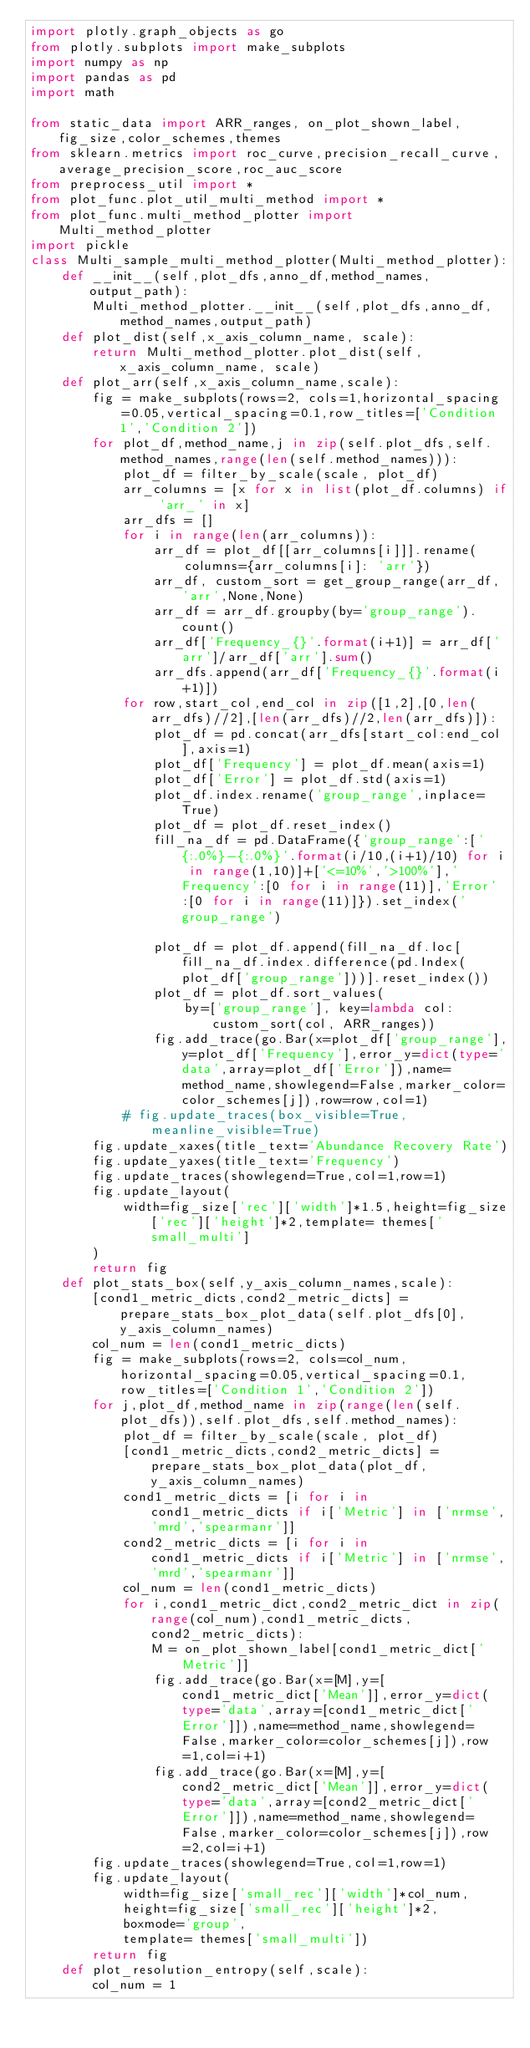<code> <loc_0><loc_0><loc_500><loc_500><_Python_>import plotly.graph_objects as go
from plotly.subplots import make_subplots
import numpy as np
import pandas as pd
import math

from static_data import ARR_ranges, on_plot_shown_label,fig_size,color_schemes,themes
from sklearn.metrics import roc_curve,precision_recall_curve,average_precision_score,roc_auc_score
from preprocess_util import *
from plot_func.plot_util_multi_method import *
from plot_func.multi_method_plotter import Multi_method_plotter
import pickle
class Multi_sample_multi_method_plotter(Multi_method_plotter):
    def __init__(self,plot_dfs,anno_df,method_names,output_path):
        Multi_method_plotter.__init__(self,plot_dfs,anno_df,method_names,output_path)
    def plot_dist(self,x_axis_column_name, scale):
        return Multi_method_plotter.plot_dist(self,x_axis_column_name, scale)
    def plot_arr(self,x_axis_column_name,scale):
        fig = make_subplots(rows=2, cols=1,horizontal_spacing=0.05,vertical_spacing=0.1,row_titles=['Condition 1','Condition 2'])
        for plot_df,method_name,j in zip(self.plot_dfs,self.method_names,range(len(self.method_names))):
            plot_df = filter_by_scale(scale, plot_df)
            arr_columns = [x for x in list(plot_df.columns) if 'arr_' in x]
            arr_dfs = []
            for i in range(len(arr_columns)):
                arr_df = plot_df[[arr_columns[i]]].rename(
                    columns={arr_columns[i]: 'arr'})
                arr_df, custom_sort = get_group_range(arr_df, 'arr',None,None)
                arr_df = arr_df.groupby(by='group_range').count()
                arr_df['Frequency_{}'.format(i+1)] = arr_df['arr']/arr_df['arr'].sum()
                arr_dfs.append(arr_df['Frequency_{}'.format(i+1)])
            for row,start_col,end_col in zip([1,2],[0,len(arr_dfs)//2],[len(arr_dfs)//2,len(arr_dfs)]):
                plot_df = pd.concat(arr_dfs[start_col:end_col],axis=1)
                plot_df['Frequency'] = plot_df.mean(axis=1)
                plot_df['Error'] = plot_df.std(axis=1)
                plot_df.index.rename('group_range',inplace=True)
                plot_df = plot_df.reset_index()
                fill_na_df = pd.DataFrame({'group_range':['{:.0%}-{:.0%}'.format(i/10,(i+1)/10) for i in range(1,10)]+['<=10%','>100%'],'Frequency':[0 for i in range(11)],'Error':[0 for i in range(11)]}).set_index('group_range')
                
                plot_df = plot_df.append(fill_na_df.loc[fill_na_df.index.difference(pd.Index(plot_df['group_range']))].reset_index())
                plot_df = plot_df.sort_values(
                    by=['group_range'], key=lambda col: custom_sort(col, ARR_ranges))
                fig.add_trace(go.Bar(x=plot_df['group_range'],y=plot_df['Frequency'],error_y=dict(type='data',array=plot_df['Error']),name=method_name,showlegend=False,marker_color=color_schemes[j]),row=row,col=1)
            # fig.update_traces(box_visible=True, meanline_visible=True)
        fig.update_xaxes(title_text='Abundance Recovery Rate')
        fig.update_yaxes(title_text='Frequency')
        fig.update_traces(showlegend=True,col=1,row=1)
        fig.update_layout(
            width=fig_size['rec']['width']*1.5,height=fig_size['rec']['height']*2,template= themes['small_multi']
        )
        return fig
    def plot_stats_box(self,y_axis_column_names,scale):
        [cond1_metric_dicts,cond2_metric_dicts] = prepare_stats_box_plot_data(self.plot_dfs[0],y_axis_column_names)
        col_num = len(cond1_metric_dicts)
        fig = make_subplots(rows=2, cols=col_num,horizontal_spacing=0.05,vertical_spacing=0.1,row_titles=['Condition 1','Condition 2'])
        for j,plot_df,method_name in zip(range(len(self.plot_dfs)),self.plot_dfs,self.method_names):
            plot_df = filter_by_scale(scale, plot_df)
            [cond1_metric_dicts,cond2_metric_dicts] = prepare_stats_box_plot_data(plot_df,y_axis_column_names)
            cond1_metric_dicts = [i for i in cond1_metric_dicts if i['Metric'] in ['nrmse','mrd','spearmanr']]
            cond2_metric_dicts = [i for i in cond1_metric_dicts if i['Metric'] in ['nrmse','mrd','spearmanr']]
            col_num = len(cond1_metric_dicts)
            for i,cond1_metric_dict,cond2_metric_dict in zip(range(col_num),cond1_metric_dicts,cond2_metric_dicts):
                M = on_plot_shown_label[cond1_metric_dict['Metric']]
                fig.add_trace(go.Bar(x=[M],y=[cond1_metric_dict['Mean']],error_y=dict(type='data',array=[cond1_metric_dict['Error']]),name=method_name,showlegend=False,marker_color=color_schemes[j]),row=1,col=i+1)
                fig.add_trace(go.Bar(x=[M],y=[cond2_metric_dict['Mean']],error_y=dict(type='data',array=[cond2_metric_dict['Error']]),name=method_name,showlegend=False,marker_color=color_schemes[j]),row=2,col=i+1)
        fig.update_traces(showlegend=True,col=1,row=1)
        fig.update_layout(
            width=fig_size['small_rec']['width']*col_num,
            height=fig_size['small_rec']['height']*2,
            boxmode='group', 
            template= themes['small_multi'])
        return fig
    def plot_resolution_entropy(self,scale):
        col_num = 1</code> 